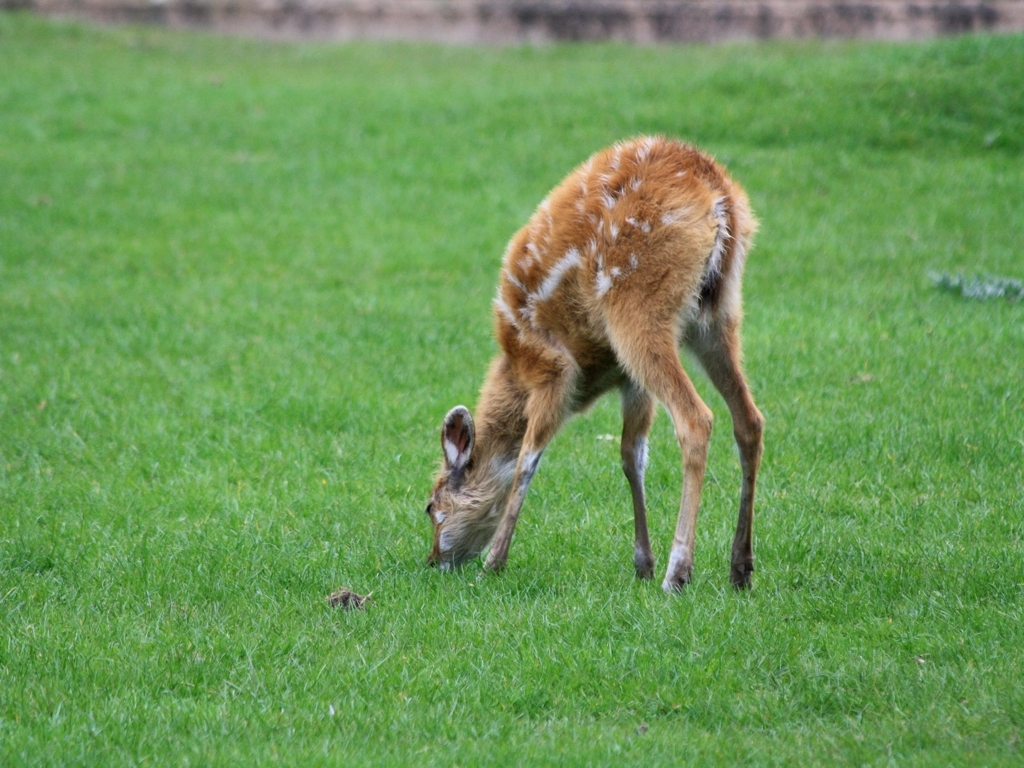What type of animal is shown in this image? The image depicts a juvenile deer, recognized by its small size, spotted coat, and long, thin legs. 